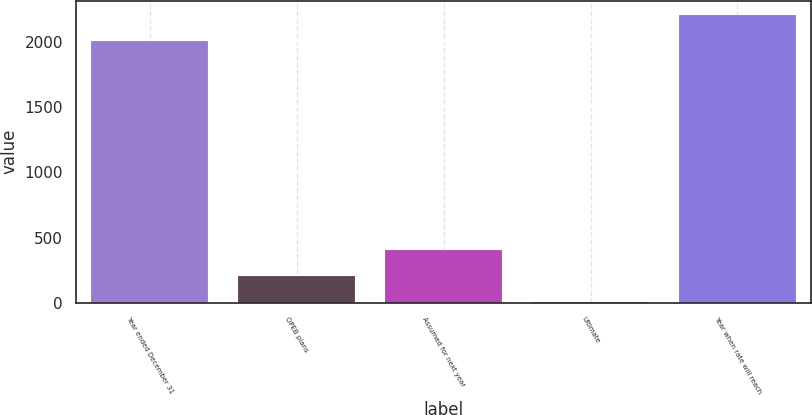Convert chart to OTSL. <chart><loc_0><loc_0><loc_500><loc_500><bar_chart><fcel>Year ended December 31<fcel>OPEB plans<fcel>Assumed for next year<fcel>Ultimate<fcel>Year when rate will reach<nl><fcel>2006<fcel>205.8<fcel>406.6<fcel>5<fcel>2206.8<nl></chart> 